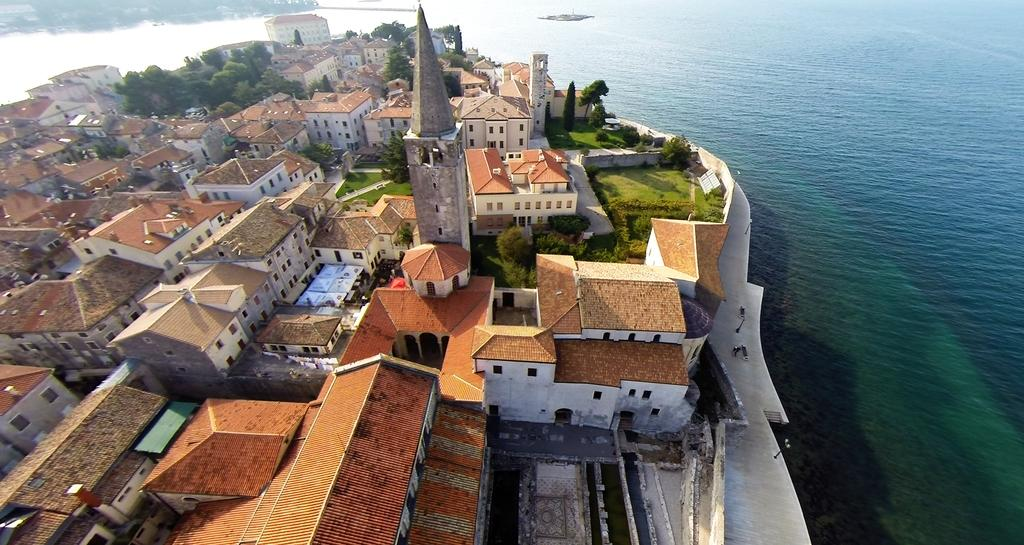What is the primary element visible in the image? There is water in the image. What type of structures can be seen in the image? There are buildings in the image. What type of vegetation is present in the image? Grass is present in the image. What other natural elements can be seen in the image? Trees are visible in the image. What type of oil can be seen floating on the water in the image? There is no oil visible in the image; it only features water, buildings, grass, and trees. 